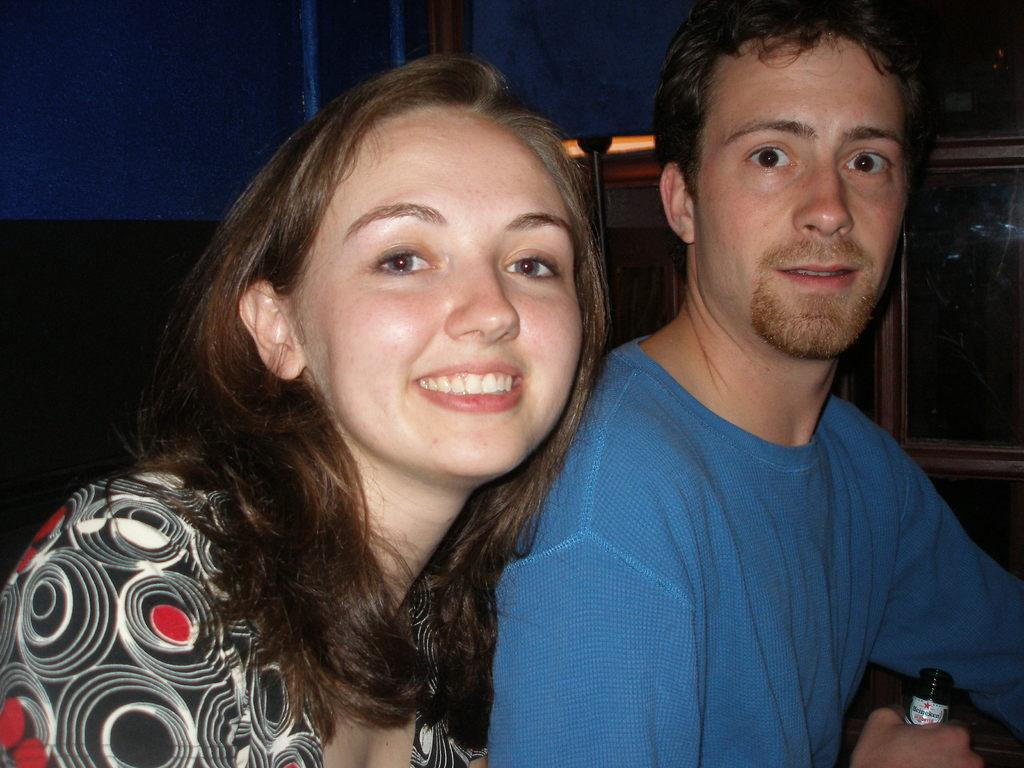How many people are present in the image? There are two persons in the image. What object can be seen besides the two persons? There is a bottle in the image. Can you describe the background of the image? There are objects in the background of the image. What type of suggestion can be seen being made by the parent in the image? There is no parent present in the image, and therefore no suggestion can be observed. 